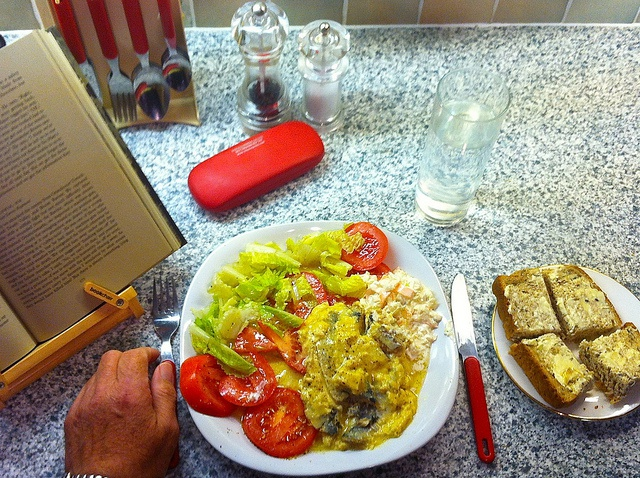Describe the objects in this image and their specific colors. I can see dining table in gray, ivory, darkgray, and lightblue tones, book in gray, maroon, and tan tones, cup in gray, beige, lightblue, darkgray, and lightgray tones, people in gray, maroon, and brown tones, and cake in gray, maroon, khaki, and olive tones in this image. 